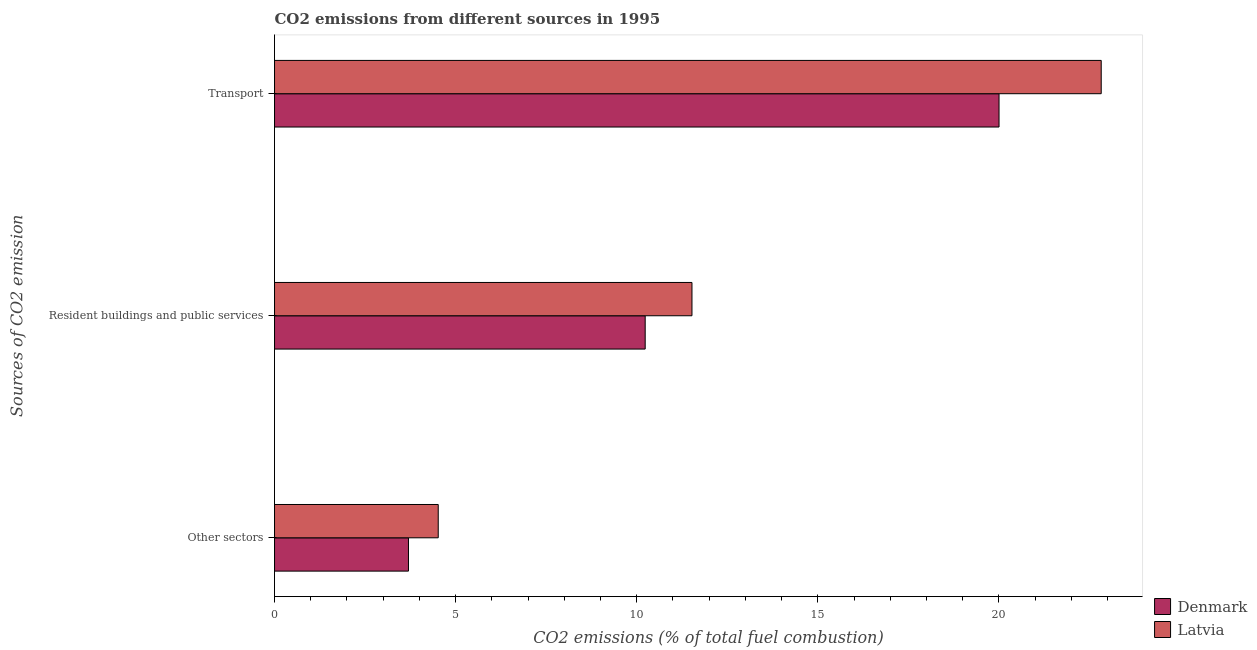How many groups of bars are there?
Ensure brevity in your answer.  3. Are the number of bars per tick equal to the number of legend labels?
Make the answer very short. Yes. Are the number of bars on each tick of the Y-axis equal?
Make the answer very short. Yes. How many bars are there on the 1st tick from the bottom?
Your response must be concise. 2. What is the label of the 3rd group of bars from the top?
Offer a very short reply. Other sectors. What is the percentage of co2 emissions from resident buildings and public services in Denmark?
Provide a succinct answer. 10.23. Across all countries, what is the maximum percentage of co2 emissions from transport?
Offer a very short reply. 22.82. Across all countries, what is the minimum percentage of co2 emissions from other sectors?
Provide a succinct answer. 3.7. In which country was the percentage of co2 emissions from transport maximum?
Ensure brevity in your answer.  Latvia. What is the total percentage of co2 emissions from other sectors in the graph?
Your answer should be compact. 8.22. What is the difference between the percentage of co2 emissions from other sectors in Denmark and that in Latvia?
Ensure brevity in your answer.  -0.82. What is the difference between the percentage of co2 emissions from other sectors in Latvia and the percentage of co2 emissions from resident buildings and public services in Denmark?
Your answer should be very brief. -5.71. What is the average percentage of co2 emissions from transport per country?
Provide a short and direct response. 21.41. What is the difference between the percentage of co2 emissions from transport and percentage of co2 emissions from resident buildings and public services in Latvia?
Your answer should be compact. 11.3. In how many countries, is the percentage of co2 emissions from transport greater than 4 %?
Offer a very short reply. 2. What is the ratio of the percentage of co2 emissions from transport in Denmark to that in Latvia?
Make the answer very short. 0.88. Is the percentage of co2 emissions from other sectors in Latvia less than that in Denmark?
Keep it short and to the point. No. What is the difference between the highest and the second highest percentage of co2 emissions from other sectors?
Keep it short and to the point. 0.82. What is the difference between the highest and the lowest percentage of co2 emissions from transport?
Make the answer very short. 2.82. In how many countries, is the percentage of co2 emissions from other sectors greater than the average percentage of co2 emissions from other sectors taken over all countries?
Ensure brevity in your answer.  1. What does the 1st bar from the top in Other sectors represents?
Offer a very short reply. Latvia. Is it the case that in every country, the sum of the percentage of co2 emissions from other sectors and percentage of co2 emissions from resident buildings and public services is greater than the percentage of co2 emissions from transport?
Provide a short and direct response. No. Are all the bars in the graph horizontal?
Your response must be concise. Yes. How many countries are there in the graph?
Provide a short and direct response. 2. Does the graph contain grids?
Provide a short and direct response. No. How many legend labels are there?
Provide a succinct answer. 2. How are the legend labels stacked?
Provide a short and direct response. Vertical. What is the title of the graph?
Your response must be concise. CO2 emissions from different sources in 1995. What is the label or title of the X-axis?
Your response must be concise. CO2 emissions (% of total fuel combustion). What is the label or title of the Y-axis?
Your response must be concise. Sources of CO2 emission. What is the CO2 emissions (% of total fuel combustion) in Denmark in Other sectors?
Offer a terse response. 3.7. What is the CO2 emissions (% of total fuel combustion) in Latvia in Other sectors?
Your answer should be compact. 4.52. What is the CO2 emissions (% of total fuel combustion) in Denmark in Resident buildings and public services?
Provide a succinct answer. 10.23. What is the CO2 emissions (% of total fuel combustion) in Latvia in Resident buildings and public services?
Make the answer very short. 11.53. What is the CO2 emissions (% of total fuel combustion) of Denmark in Transport?
Your response must be concise. 20. What is the CO2 emissions (% of total fuel combustion) of Latvia in Transport?
Give a very brief answer. 22.82. Across all Sources of CO2 emission, what is the maximum CO2 emissions (% of total fuel combustion) of Denmark?
Provide a short and direct response. 20. Across all Sources of CO2 emission, what is the maximum CO2 emissions (% of total fuel combustion) of Latvia?
Make the answer very short. 22.82. Across all Sources of CO2 emission, what is the minimum CO2 emissions (% of total fuel combustion) in Denmark?
Give a very brief answer. 3.7. Across all Sources of CO2 emission, what is the minimum CO2 emissions (% of total fuel combustion) of Latvia?
Your answer should be compact. 4.52. What is the total CO2 emissions (% of total fuel combustion) in Denmark in the graph?
Your answer should be compact. 33.94. What is the total CO2 emissions (% of total fuel combustion) of Latvia in the graph?
Your answer should be compact. 38.87. What is the difference between the CO2 emissions (% of total fuel combustion) in Denmark in Other sectors and that in Resident buildings and public services?
Give a very brief answer. -6.54. What is the difference between the CO2 emissions (% of total fuel combustion) of Latvia in Other sectors and that in Resident buildings and public services?
Provide a succinct answer. -7.01. What is the difference between the CO2 emissions (% of total fuel combustion) in Denmark in Other sectors and that in Transport?
Give a very brief answer. -16.31. What is the difference between the CO2 emissions (% of total fuel combustion) of Latvia in Other sectors and that in Transport?
Give a very brief answer. -18.31. What is the difference between the CO2 emissions (% of total fuel combustion) of Denmark in Resident buildings and public services and that in Transport?
Your answer should be very brief. -9.77. What is the difference between the CO2 emissions (% of total fuel combustion) in Latvia in Resident buildings and public services and that in Transport?
Provide a short and direct response. -11.3. What is the difference between the CO2 emissions (% of total fuel combustion) in Denmark in Other sectors and the CO2 emissions (% of total fuel combustion) in Latvia in Resident buildings and public services?
Offer a very short reply. -7.83. What is the difference between the CO2 emissions (% of total fuel combustion) in Denmark in Other sectors and the CO2 emissions (% of total fuel combustion) in Latvia in Transport?
Your response must be concise. -19.13. What is the difference between the CO2 emissions (% of total fuel combustion) in Denmark in Resident buildings and public services and the CO2 emissions (% of total fuel combustion) in Latvia in Transport?
Give a very brief answer. -12.59. What is the average CO2 emissions (% of total fuel combustion) of Denmark per Sources of CO2 emission?
Your response must be concise. 11.31. What is the average CO2 emissions (% of total fuel combustion) in Latvia per Sources of CO2 emission?
Offer a very short reply. 12.96. What is the difference between the CO2 emissions (% of total fuel combustion) of Denmark and CO2 emissions (% of total fuel combustion) of Latvia in Other sectors?
Provide a succinct answer. -0.82. What is the difference between the CO2 emissions (% of total fuel combustion) of Denmark and CO2 emissions (% of total fuel combustion) of Latvia in Resident buildings and public services?
Offer a very short reply. -1.29. What is the difference between the CO2 emissions (% of total fuel combustion) of Denmark and CO2 emissions (% of total fuel combustion) of Latvia in Transport?
Ensure brevity in your answer.  -2.82. What is the ratio of the CO2 emissions (% of total fuel combustion) in Denmark in Other sectors to that in Resident buildings and public services?
Offer a very short reply. 0.36. What is the ratio of the CO2 emissions (% of total fuel combustion) of Latvia in Other sectors to that in Resident buildings and public services?
Your response must be concise. 0.39. What is the ratio of the CO2 emissions (% of total fuel combustion) of Denmark in Other sectors to that in Transport?
Your answer should be very brief. 0.18. What is the ratio of the CO2 emissions (% of total fuel combustion) of Latvia in Other sectors to that in Transport?
Your answer should be compact. 0.2. What is the ratio of the CO2 emissions (% of total fuel combustion) of Denmark in Resident buildings and public services to that in Transport?
Your response must be concise. 0.51. What is the ratio of the CO2 emissions (% of total fuel combustion) in Latvia in Resident buildings and public services to that in Transport?
Your answer should be compact. 0.51. What is the difference between the highest and the second highest CO2 emissions (% of total fuel combustion) of Denmark?
Your answer should be compact. 9.77. What is the difference between the highest and the second highest CO2 emissions (% of total fuel combustion) of Latvia?
Your response must be concise. 11.3. What is the difference between the highest and the lowest CO2 emissions (% of total fuel combustion) of Denmark?
Give a very brief answer. 16.31. What is the difference between the highest and the lowest CO2 emissions (% of total fuel combustion) of Latvia?
Keep it short and to the point. 18.31. 